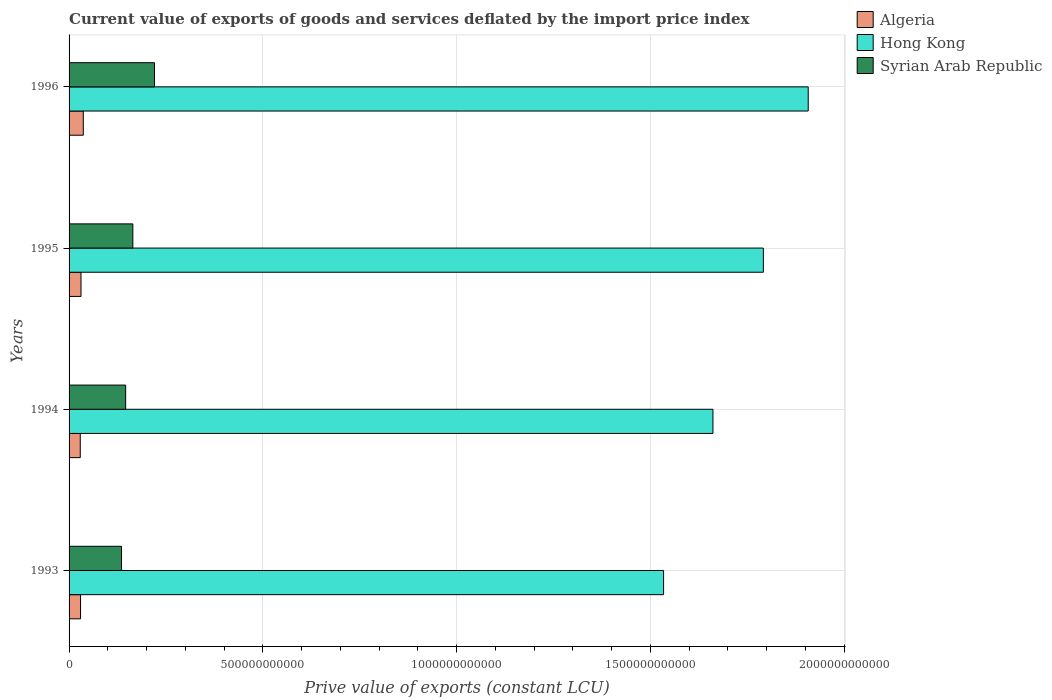How many different coloured bars are there?
Provide a succinct answer. 3. How many groups of bars are there?
Keep it short and to the point. 4. Are the number of bars on each tick of the Y-axis equal?
Your answer should be compact. Yes. How many bars are there on the 2nd tick from the top?
Provide a succinct answer. 3. How many bars are there on the 1st tick from the bottom?
Ensure brevity in your answer.  3. What is the label of the 3rd group of bars from the top?
Give a very brief answer. 1994. In how many cases, is the number of bars for a given year not equal to the number of legend labels?
Make the answer very short. 0. What is the prive value of exports in Algeria in 1993?
Your response must be concise. 2.96e+1. Across all years, what is the maximum prive value of exports in Algeria?
Provide a short and direct response. 3.67e+1. Across all years, what is the minimum prive value of exports in Syrian Arab Republic?
Your response must be concise. 1.35e+11. In which year was the prive value of exports in Algeria maximum?
Your answer should be very brief. 1996. What is the total prive value of exports in Hong Kong in the graph?
Your response must be concise. 6.90e+12. What is the difference between the prive value of exports in Syrian Arab Republic in 1993 and that in 1994?
Offer a very short reply. -1.07e+1. What is the difference between the prive value of exports in Algeria in 1994 and the prive value of exports in Hong Kong in 1996?
Keep it short and to the point. -1.88e+12. What is the average prive value of exports in Hong Kong per year?
Provide a short and direct response. 1.72e+12. In the year 1994, what is the difference between the prive value of exports in Syrian Arab Republic and prive value of exports in Hong Kong?
Your answer should be compact. -1.52e+12. In how many years, is the prive value of exports in Hong Kong greater than 1700000000000 LCU?
Your answer should be compact. 2. What is the ratio of the prive value of exports in Algeria in 1994 to that in 1996?
Your response must be concise. 0.79. Is the prive value of exports in Algeria in 1993 less than that in 1995?
Make the answer very short. Yes. What is the difference between the highest and the second highest prive value of exports in Hong Kong?
Provide a succinct answer. 1.16e+11. What is the difference between the highest and the lowest prive value of exports in Hong Kong?
Your response must be concise. 3.73e+11. What does the 1st bar from the top in 1993 represents?
Your answer should be compact. Syrian Arab Republic. What does the 3rd bar from the bottom in 1993 represents?
Your response must be concise. Syrian Arab Republic. Is it the case that in every year, the sum of the prive value of exports in Algeria and prive value of exports in Syrian Arab Republic is greater than the prive value of exports in Hong Kong?
Offer a terse response. No. How many bars are there?
Offer a very short reply. 12. Are all the bars in the graph horizontal?
Offer a terse response. Yes. What is the difference between two consecutive major ticks on the X-axis?
Ensure brevity in your answer.  5.00e+11. Does the graph contain any zero values?
Make the answer very short. No. Does the graph contain grids?
Give a very brief answer. Yes. How many legend labels are there?
Make the answer very short. 3. What is the title of the graph?
Provide a short and direct response. Current value of exports of goods and services deflated by the import price index. What is the label or title of the X-axis?
Ensure brevity in your answer.  Prive value of exports (constant LCU). What is the label or title of the Y-axis?
Ensure brevity in your answer.  Years. What is the Prive value of exports (constant LCU) in Algeria in 1993?
Your answer should be compact. 2.96e+1. What is the Prive value of exports (constant LCU) in Hong Kong in 1993?
Give a very brief answer. 1.53e+12. What is the Prive value of exports (constant LCU) in Syrian Arab Republic in 1993?
Keep it short and to the point. 1.35e+11. What is the Prive value of exports (constant LCU) in Algeria in 1994?
Provide a succinct answer. 2.89e+1. What is the Prive value of exports (constant LCU) in Hong Kong in 1994?
Keep it short and to the point. 1.66e+12. What is the Prive value of exports (constant LCU) of Syrian Arab Republic in 1994?
Provide a succinct answer. 1.46e+11. What is the Prive value of exports (constant LCU) in Algeria in 1995?
Your answer should be very brief. 3.08e+1. What is the Prive value of exports (constant LCU) in Hong Kong in 1995?
Give a very brief answer. 1.79e+12. What is the Prive value of exports (constant LCU) in Syrian Arab Republic in 1995?
Make the answer very short. 1.65e+11. What is the Prive value of exports (constant LCU) in Algeria in 1996?
Your response must be concise. 3.67e+1. What is the Prive value of exports (constant LCU) in Hong Kong in 1996?
Your answer should be very brief. 1.91e+12. What is the Prive value of exports (constant LCU) of Syrian Arab Republic in 1996?
Offer a very short reply. 2.20e+11. Across all years, what is the maximum Prive value of exports (constant LCU) in Algeria?
Provide a succinct answer. 3.67e+1. Across all years, what is the maximum Prive value of exports (constant LCU) of Hong Kong?
Your answer should be compact. 1.91e+12. Across all years, what is the maximum Prive value of exports (constant LCU) in Syrian Arab Republic?
Your response must be concise. 2.20e+11. Across all years, what is the minimum Prive value of exports (constant LCU) of Algeria?
Your answer should be very brief. 2.89e+1. Across all years, what is the minimum Prive value of exports (constant LCU) of Hong Kong?
Provide a succinct answer. 1.53e+12. Across all years, what is the minimum Prive value of exports (constant LCU) of Syrian Arab Republic?
Ensure brevity in your answer.  1.35e+11. What is the total Prive value of exports (constant LCU) of Algeria in the graph?
Your response must be concise. 1.26e+11. What is the total Prive value of exports (constant LCU) of Hong Kong in the graph?
Your answer should be compact. 6.90e+12. What is the total Prive value of exports (constant LCU) in Syrian Arab Republic in the graph?
Offer a terse response. 6.66e+11. What is the difference between the Prive value of exports (constant LCU) in Algeria in 1993 and that in 1994?
Your answer should be very brief. 7.53e+08. What is the difference between the Prive value of exports (constant LCU) in Hong Kong in 1993 and that in 1994?
Your answer should be very brief. -1.27e+11. What is the difference between the Prive value of exports (constant LCU) in Syrian Arab Republic in 1993 and that in 1994?
Your answer should be very brief. -1.07e+1. What is the difference between the Prive value of exports (constant LCU) of Algeria in 1993 and that in 1995?
Make the answer very short. -1.14e+09. What is the difference between the Prive value of exports (constant LCU) of Hong Kong in 1993 and that in 1995?
Your answer should be very brief. -2.58e+11. What is the difference between the Prive value of exports (constant LCU) in Syrian Arab Republic in 1993 and that in 1995?
Offer a terse response. -2.93e+1. What is the difference between the Prive value of exports (constant LCU) in Algeria in 1993 and that in 1996?
Provide a succinct answer. -7.07e+09. What is the difference between the Prive value of exports (constant LCU) in Hong Kong in 1993 and that in 1996?
Give a very brief answer. -3.73e+11. What is the difference between the Prive value of exports (constant LCU) of Syrian Arab Republic in 1993 and that in 1996?
Your answer should be very brief. -8.51e+1. What is the difference between the Prive value of exports (constant LCU) in Algeria in 1994 and that in 1995?
Provide a succinct answer. -1.89e+09. What is the difference between the Prive value of exports (constant LCU) of Hong Kong in 1994 and that in 1995?
Your answer should be compact. -1.30e+11. What is the difference between the Prive value of exports (constant LCU) in Syrian Arab Republic in 1994 and that in 1995?
Your response must be concise. -1.85e+1. What is the difference between the Prive value of exports (constant LCU) in Algeria in 1994 and that in 1996?
Offer a very short reply. -7.83e+09. What is the difference between the Prive value of exports (constant LCU) of Hong Kong in 1994 and that in 1996?
Your answer should be compact. -2.46e+11. What is the difference between the Prive value of exports (constant LCU) of Syrian Arab Republic in 1994 and that in 1996?
Offer a terse response. -7.44e+1. What is the difference between the Prive value of exports (constant LCU) in Algeria in 1995 and that in 1996?
Your response must be concise. -5.93e+09. What is the difference between the Prive value of exports (constant LCU) of Hong Kong in 1995 and that in 1996?
Your answer should be very brief. -1.16e+11. What is the difference between the Prive value of exports (constant LCU) of Syrian Arab Republic in 1995 and that in 1996?
Your response must be concise. -5.59e+1. What is the difference between the Prive value of exports (constant LCU) of Algeria in 1993 and the Prive value of exports (constant LCU) of Hong Kong in 1994?
Your answer should be compact. -1.63e+12. What is the difference between the Prive value of exports (constant LCU) in Algeria in 1993 and the Prive value of exports (constant LCU) in Syrian Arab Republic in 1994?
Give a very brief answer. -1.16e+11. What is the difference between the Prive value of exports (constant LCU) in Hong Kong in 1993 and the Prive value of exports (constant LCU) in Syrian Arab Republic in 1994?
Make the answer very short. 1.39e+12. What is the difference between the Prive value of exports (constant LCU) of Algeria in 1993 and the Prive value of exports (constant LCU) of Hong Kong in 1995?
Give a very brief answer. -1.76e+12. What is the difference between the Prive value of exports (constant LCU) of Algeria in 1993 and the Prive value of exports (constant LCU) of Syrian Arab Republic in 1995?
Keep it short and to the point. -1.35e+11. What is the difference between the Prive value of exports (constant LCU) of Hong Kong in 1993 and the Prive value of exports (constant LCU) of Syrian Arab Republic in 1995?
Offer a very short reply. 1.37e+12. What is the difference between the Prive value of exports (constant LCU) in Algeria in 1993 and the Prive value of exports (constant LCU) in Hong Kong in 1996?
Keep it short and to the point. -1.88e+12. What is the difference between the Prive value of exports (constant LCU) in Algeria in 1993 and the Prive value of exports (constant LCU) in Syrian Arab Republic in 1996?
Offer a very short reply. -1.91e+11. What is the difference between the Prive value of exports (constant LCU) in Hong Kong in 1993 and the Prive value of exports (constant LCU) in Syrian Arab Republic in 1996?
Give a very brief answer. 1.31e+12. What is the difference between the Prive value of exports (constant LCU) in Algeria in 1994 and the Prive value of exports (constant LCU) in Hong Kong in 1995?
Your answer should be compact. -1.76e+12. What is the difference between the Prive value of exports (constant LCU) in Algeria in 1994 and the Prive value of exports (constant LCU) in Syrian Arab Republic in 1995?
Make the answer very short. -1.36e+11. What is the difference between the Prive value of exports (constant LCU) in Hong Kong in 1994 and the Prive value of exports (constant LCU) in Syrian Arab Republic in 1995?
Your answer should be compact. 1.50e+12. What is the difference between the Prive value of exports (constant LCU) of Algeria in 1994 and the Prive value of exports (constant LCU) of Hong Kong in 1996?
Your answer should be compact. -1.88e+12. What is the difference between the Prive value of exports (constant LCU) in Algeria in 1994 and the Prive value of exports (constant LCU) in Syrian Arab Republic in 1996?
Provide a short and direct response. -1.92e+11. What is the difference between the Prive value of exports (constant LCU) of Hong Kong in 1994 and the Prive value of exports (constant LCU) of Syrian Arab Republic in 1996?
Provide a short and direct response. 1.44e+12. What is the difference between the Prive value of exports (constant LCU) of Algeria in 1995 and the Prive value of exports (constant LCU) of Hong Kong in 1996?
Your answer should be compact. -1.88e+12. What is the difference between the Prive value of exports (constant LCU) of Algeria in 1995 and the Prive value of exports (constant LCU) of Syrian Arab Republic in 1996?
Your response must be concise. -1.90e+11. What is the difference between the Prive value of exports (constant LCU) in Hong Kong in 1995 and the Prive value of exports (constant LCU) in Syrian Arab Republic in 1996?
Your answer should be compact. 1.57e+12. What is the average Prive value of exports (constant LCU) of Algeria per year?
Provide a succinct answer. 3.15e+1. What is the average Prive value of exports (constant LCU) in Hong Kong per year?
Ensure brevity in your answer.  1.72e+12. What is the average Prive value of exports (constant LCU) of Syrian Arab Republic per year?
Keep it short and to the point. 1.67e+11. In the year 1993, what is the difference between the Prive value of exports (constant LCU) of Algeria and Prive value of exports (constant LCU) of Hong Kong?
Give a very brief answer. -1.50e+12. In the year 1993, what is the difference between the Prive value of exports (constant LCU) in Algeria and Prive value of exports (constant LCU) in Syrian Arab Republic?
Your answer should be very brief. -1.06e+11. In the year 1993, what is the difference between the Prive value of exports (constant LCU) in Hong Kong and Prive value of exports (constant LCU) in Syrian Arab Republic?
Your answer should be compact. 1.40e+12. In the year 1994, what is the difference between the Prive value of exports (constant LCU) in Algeria and Prive value of exports (constant LCU) in Hong Kong?
Your answer should be very brief. -1.63e+12. In the year 1994, what is the difference between the Prive value of exports (constant LCU) in Algeria and Prive value of exports (constant LCU) in Syrian Arab Republic?
Give a very brief answer. -1.17e+11. In the year 1994, what is the difference between the Prive value of exports (constant LCU) of Hong Kong and Prive value of exports (constant LCU) of Syrian Arab Republic?
Your answer should be compact. 1.52e+12. In the year 1995, what is the difference between the Prive value of exports (constant LCU) of Algeria and Prive value of exports (constant LCU) of Hong Kong?
Keep it short and to the point. -1.76e+12. In the year 1995, what is the difference between the Prive value of exports (constant LCU) in Algeria and Prive value of exports (constant LCU) in Syrian Arab Republic?
Your answer should be compact. -1.34e+11. In the year 1995, what is the difference between the Prive value of exports (constant LCU) of Hong Kong and Prive value of exports (constant LCU) of Syrian Arab Republic?
Provide a short and direct response. 1.63e+12. In the year 1996, what is the difference between the Prive value of exports (constant LCU) in Algeria and Prive value of exports (constant LCU) in Hong Kong?
Offer a terse response. -1.87e+12. In the year 1996, what is the difference between the Prive value of exports (constant LCU) in Algeria and Prive value of exports (constant LCU) in Syrian Arab Republic?
Ensure brevity in your answer.  -1.84e+11. In the year 1996, what is the difference between the Prive value of exports (constant LCU) in Hong Kong and Prive value of exports (constant LCU) in Syrian Arab Republic?
Your answer should be compact. 1.69e+12. What is the ratio of the Prive value of exports (constant LCU) in Algeria in 1993 to that in 1994?
Provide a short and direct response. 1.03. What is the ratio of the Prive value of exports (constant LCU) of Hong Kong in 1993 to that in 1994?
Make the answer very short. 0.92. What is the ratio of the Prive value of exports (constant LCU) of Syrian Arab Republic in 1993 to that in 1994?
Your response must be concise. 0.93. What is the ratio of the Prive value of exports (constant LCU) of Algeria in 1993 to that in 1995?
Offer a terse response. 0.96. What is the ratio of the Prive value of exports (constant LCU) in Hong Kong in 1993 to that in 1995?
Provide a succinct answer. 0.86. What is the ratio of the Prive value of exports (constant LCU) of Syrian Arab Republic in 1993 to that in 1995?
Make the answer very short. 0.82. What is the ratio of the Prive value of exports (constant LCU) of Algeria in 1993 to that in 1996?
Your answer should be very brief. 0.81. What is the ratio of the Prive value of exports (constant LCU) of Hong Kong in 1993 to that in 1996?
Your answer should be compact. 0.8. What is the ratio of the Prive value of exports (constant LCU) in Syrian Arab Republic in 1993 to that in 1996?
Provide a succinct answer. 0.61. What is the ratio of the Prive value of exports (constant LCU) in Algeria in 1994 to that in 1995?
Offer a very short reply. 0.94. What is the ratio of the Prive value of exports (constant LCU) in Hong Kong in 1994 to that in 1995?
Your answer should be very brief. 0.93. What is the ratio of the Prive value of exports (constant LCU) of Syrian Arab Republic in 1994 to that in 1995?
Make the answer very short. 0.89. What is the ratio of the Prive value of exports (constant LCU) of Algeria in 1994 to that in 1996?
Offer a very short reply. 0.79. What is the ratio of the Prive value of exports (constant LCU) in Hong Kong in 1994 to that in 1996?
Your answer should be very brief. 0.87. What is the ratio of the Prive value of exports (constant LCU) of Syrian Arab Republic in 1994 to that in 1996?
Keep it short and to the point. 0.66. What is the ratio of the Prive value of exports (constant LCU) in Algeria in 1995 to that in 1996?
Offer a very short reply. 0.84. What is the ratio of the Prive value of exports (constant LCU) in Hong Kong in 1995 to that in 1996?
Make the answer very short. 0.94. What is the ratio of the Prive value of exports (constant LCU) in Syrian Arab Republic in 1995 to that in 1996?
Provide a succinct answer. 0.75. What is the difference between the highest and the second highest Prive value of exports (constant LCU) in Algeria?
Provide a succinct answer. 5.93e+09. What is the difference between the highest and the second highest Prive value of exports (constant LCU) in Hong Kong?
Your answer should be compact. 1.16e+11. What is the difference between the highest and the second highest Prive value of exports (constant LCU) of Syrian Arab Republic?
Provide a short and direct response. 5.59e+1. What is the difference between the highest and the lowest Prive value of exports (constant LCU) in Algeria?
Ensure brevity in your answer.  7.83e+09. What is the difference between the highest and the lowest Prive value of exports (constant LCU) in Hong Kong?
Make the answer very short. 3.73e+11. What is the difference between the highest and the lowest Prive value of exports (constant LCU) of Syrian Arab Republic?
Your answer should be compact. 8.51e+1. 